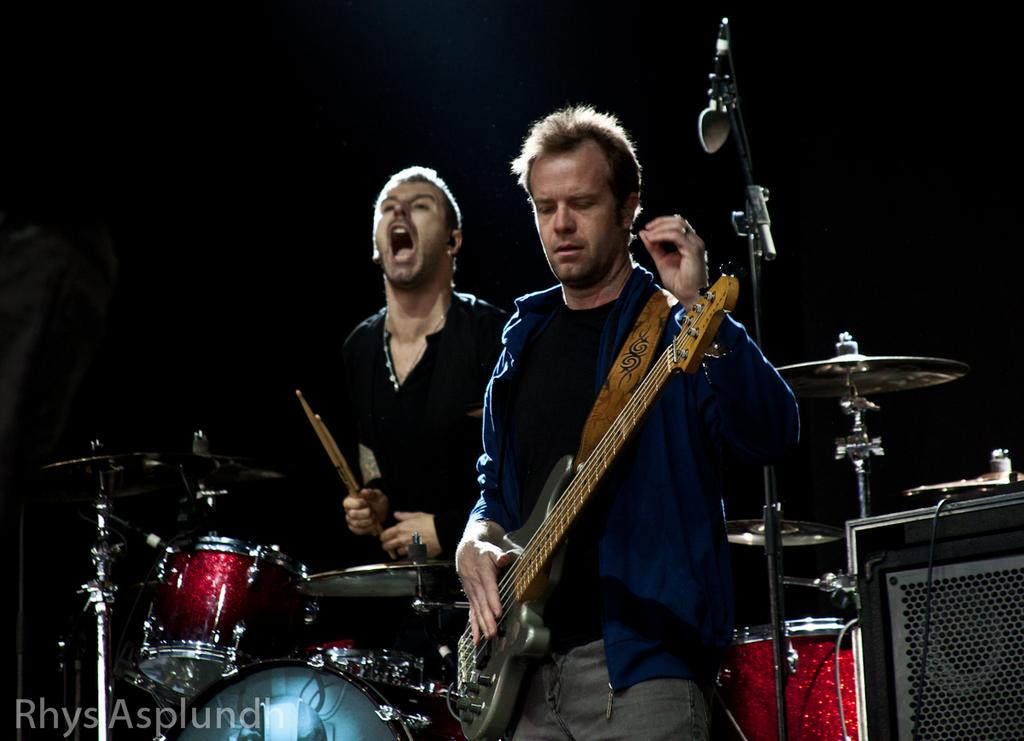How many people are in the image? There are two people in the image. What are the two people doing in the image? One person is playing a guitar, and another person is playing drums. What object is present for amplifying sound in the image? There is a microphone in the image. How many chairs are visible in the image? There are no chairs visible in the image. What type of underwear is the person playing the guitar wearing? There is no information about the person's underwear in the image. 